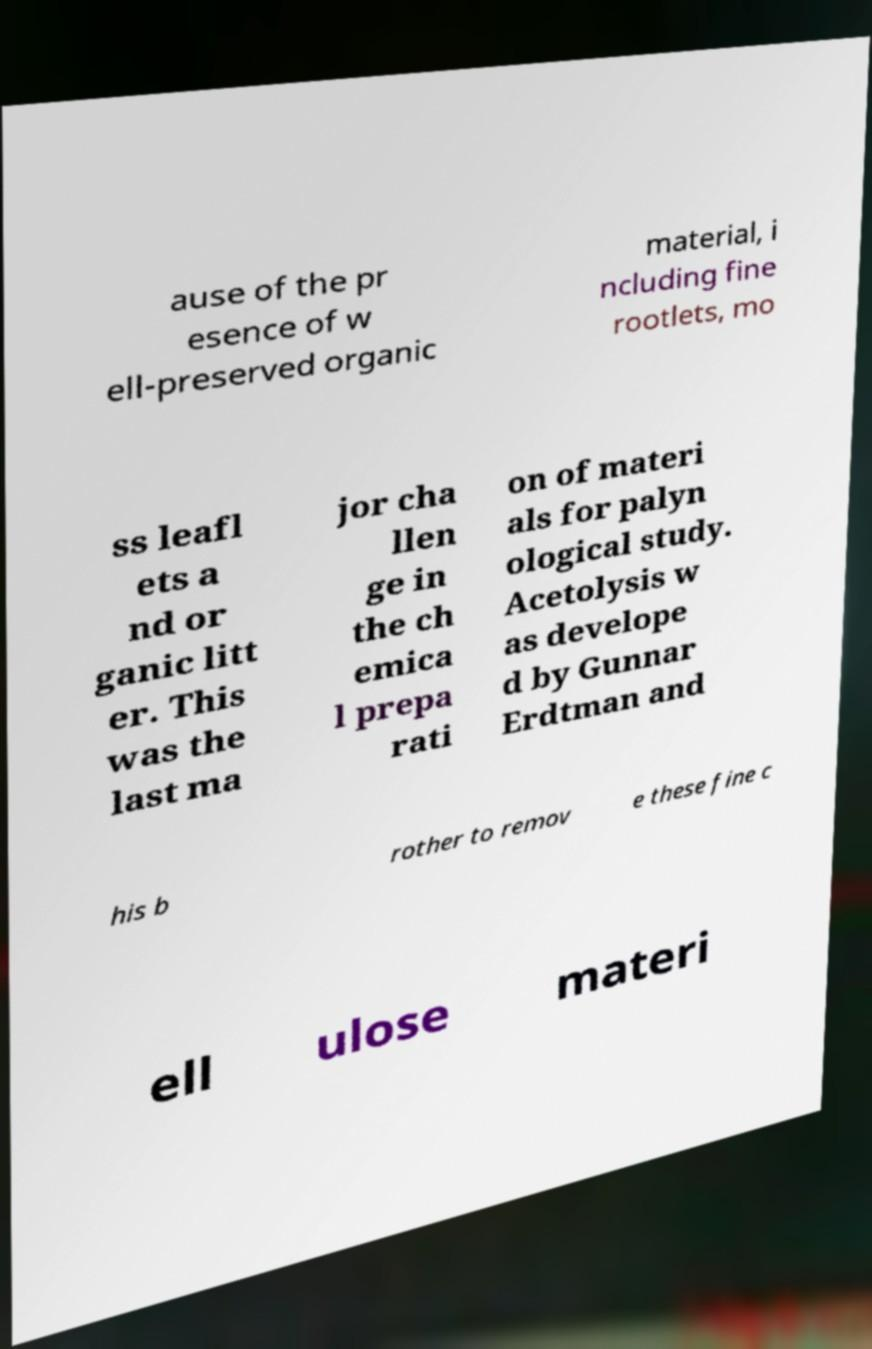Can you read and provide the text displayed in the image?This photo seems to have some interesting text. Can you extract and type it out for me? ause of the pr esence of w ell-preserved organic material, i ncluding fine rootlets, mo ss leafl ets a nd or ganic litt er. This was the last ma jor cha llen ge in the ch emica l prepa rati on of materi als for palyn ological study. Acetolysis w as develope d by Gunnar Erdtman and his b rother to remov e these fine c ell ulose materi 